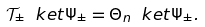Convert formula to latex. <formula><loc_0><loc_0><loc_500><loc_500>\mathcal { T } _ { \pm } \ k e t { \Psi _ { \pm } } = \Theta _ { n } \ k e t { \Psi _ { \pm } } .</formula> 